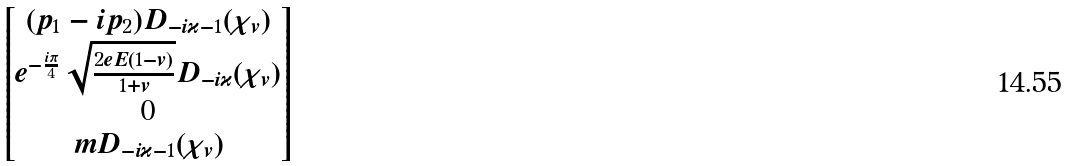Convert formula to latex. <formula><loc_0><loc_0><loc_500><loc_500>\begin{bmatrix} ( p _ { 1 } - i p _ { 2 } ) D _ { - i \varkappa - 1 } ( \chi _ { v } ) \\ e ^ { - \frac { i \pi } 4 } \sqrt { \frac { 2 e E ( 1 - v ) } { 1 + v } } D _ { - i \varkappa } ( \chi _ { v } ) \\ 0 \\ m D _ { - i \varkappa - 1 } ( \chi _ { v } ) \end{bmatrix}</formula> 